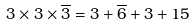Convert formula to latex. <formula><loc_0><loc_0><loc_500><loc_500>3 \times 3 \times \overline { 3 } = 3 + \overline { 6 } + 3 + 1 5</formula> 